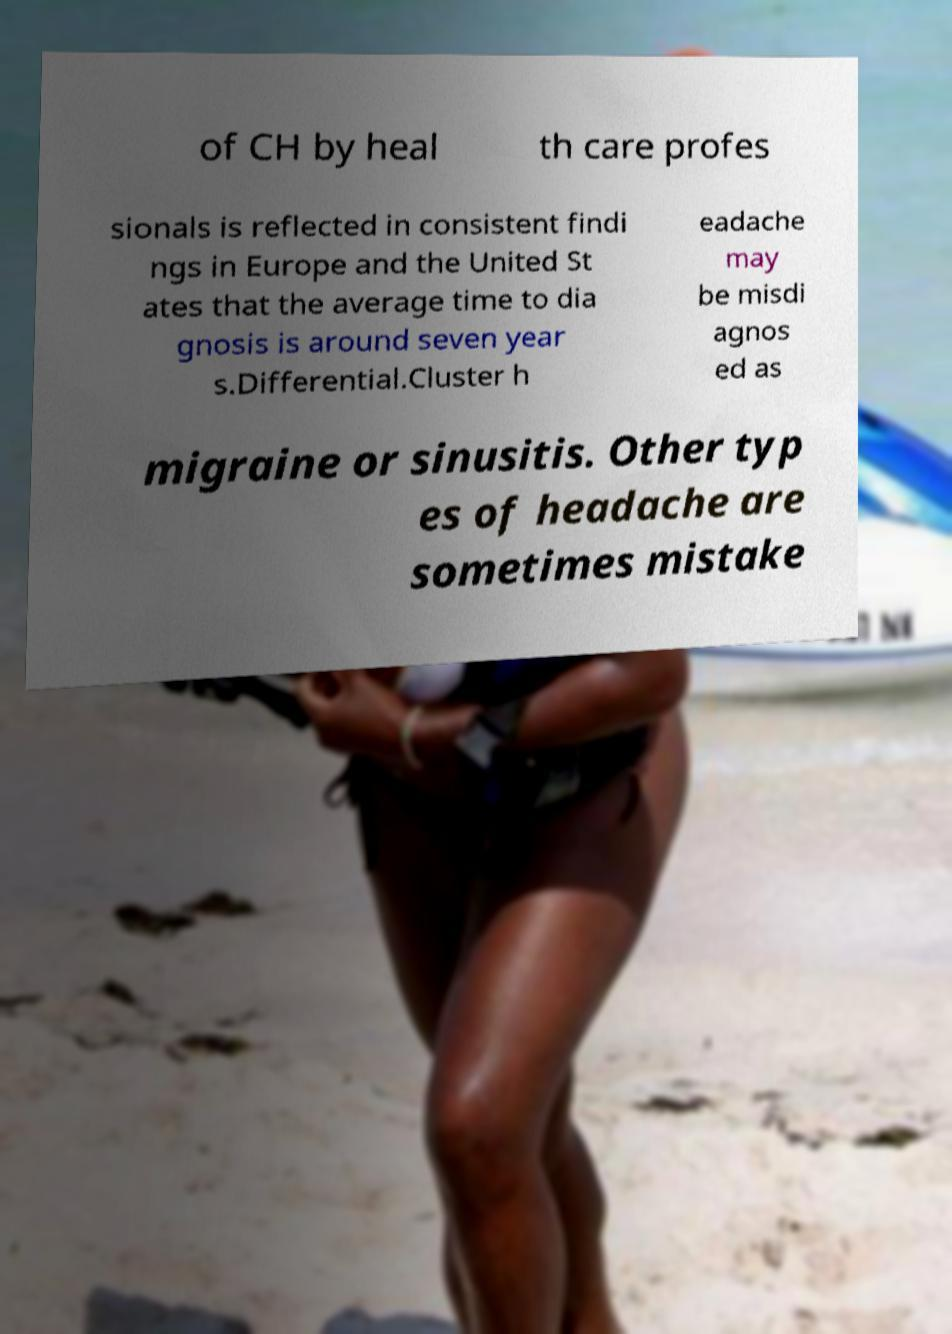For documentation purposes, I need the text within this image transcribed. Could you provide that? of CH by heal th care profes sionals is reflected in consistent findi ngs in Europe and the United St ates that the average time to dia gnosis is around seven year s.Differential.Cluster h eadache may be misdi agnos ed as migraine or sinusitis. Other typ es of headache are sometimes mistake 